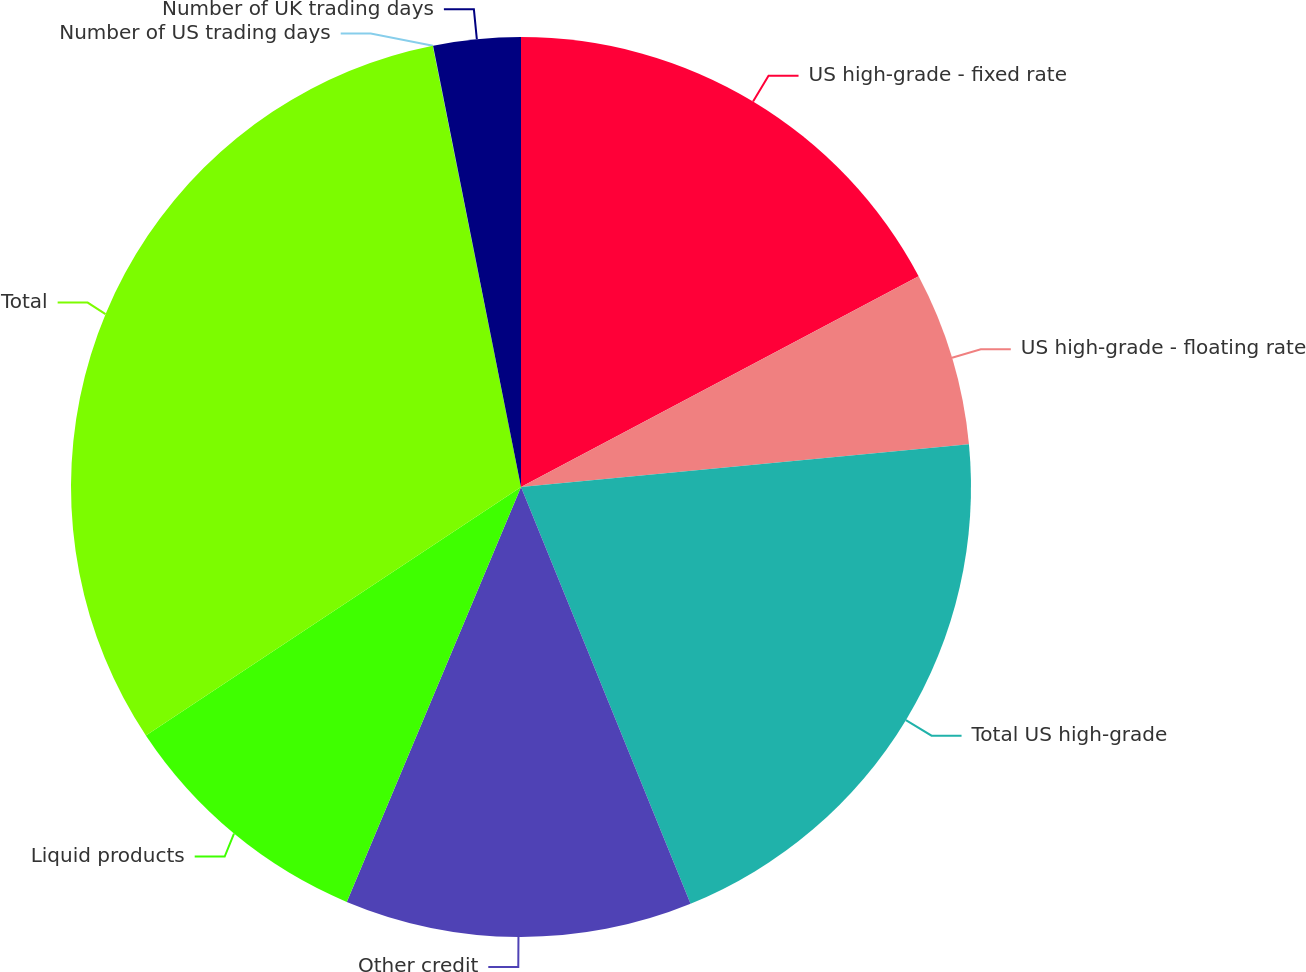<chart> <loc_0><loc_0><loc_500><loc_500><pie_chart><fcel>US high-grade - fixed rate<fcel>US high-grade - floating rate<fcel>Total US high-grade<fcel>Other credit<fcel>Liquid products<fcel>Total<fcel>Number of US trading days<fcel>Number of UK trading days<nl><fcel>17.25%<fcel>6.24%<fcel>20.37%<fcel>12.48%<fcel>9.36%<fcel>31.18%<fcel>0.01%<fcel>3.13%<nl></chart> 